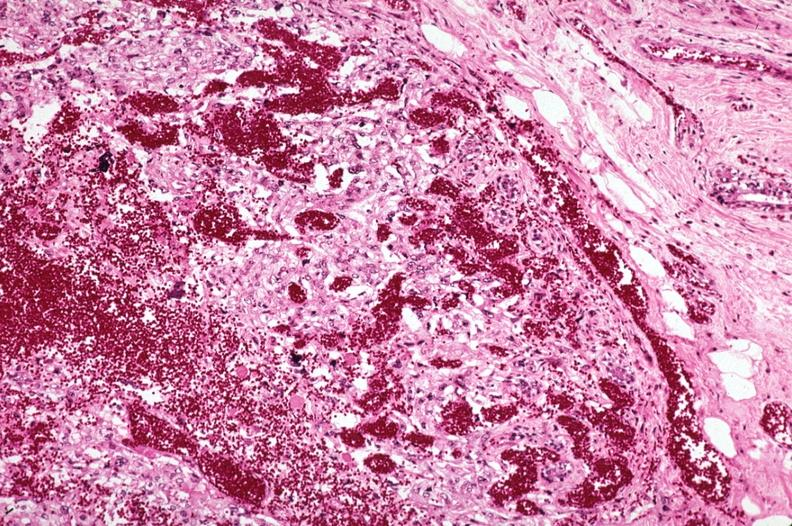what is present?
Answer the question using a single word or phrase. Breast 